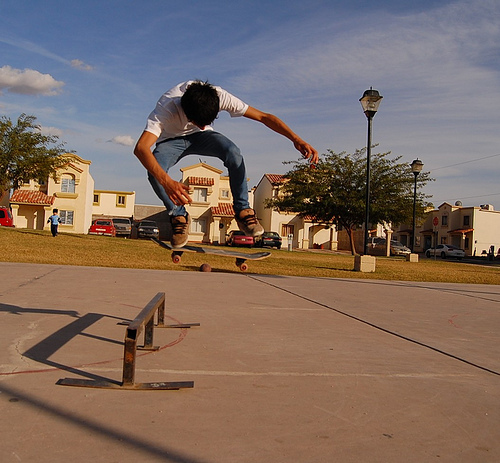How many coca-cola bottles are there? 0 